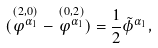Convert formula to latex. <formula><loc_0><loc_0><loc_500><loc_500>( \stackrel { ( 2 , 0 ) } { \varphi ^ { \alpha _ { 1 } } } - \stackrel { ( 0 , 2 ) } { \varphi ^ { \alpha _ { 1 } } } ) = \frac { 1 } { 2 } \tilde { \phi } ^ { \alpha _ { 1 } } ,</formula> 